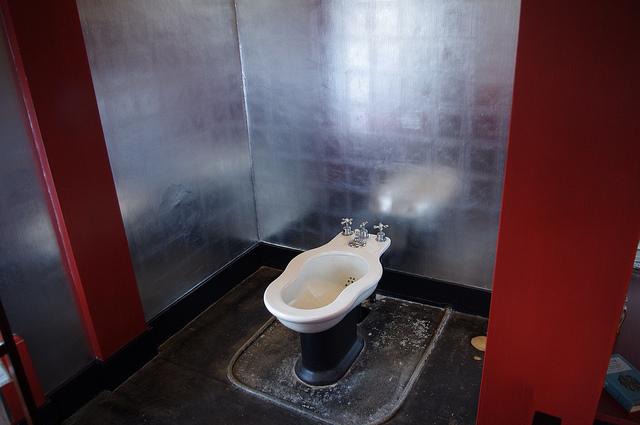Is the toilet clean?
Give a very brief answer. No. Is there a reflection?
Give a very brief answer. Yes. What color is the toilet seat?
Short answer required. White. Do the long shadows suggest it is well past morning?
Be succinct. No. 